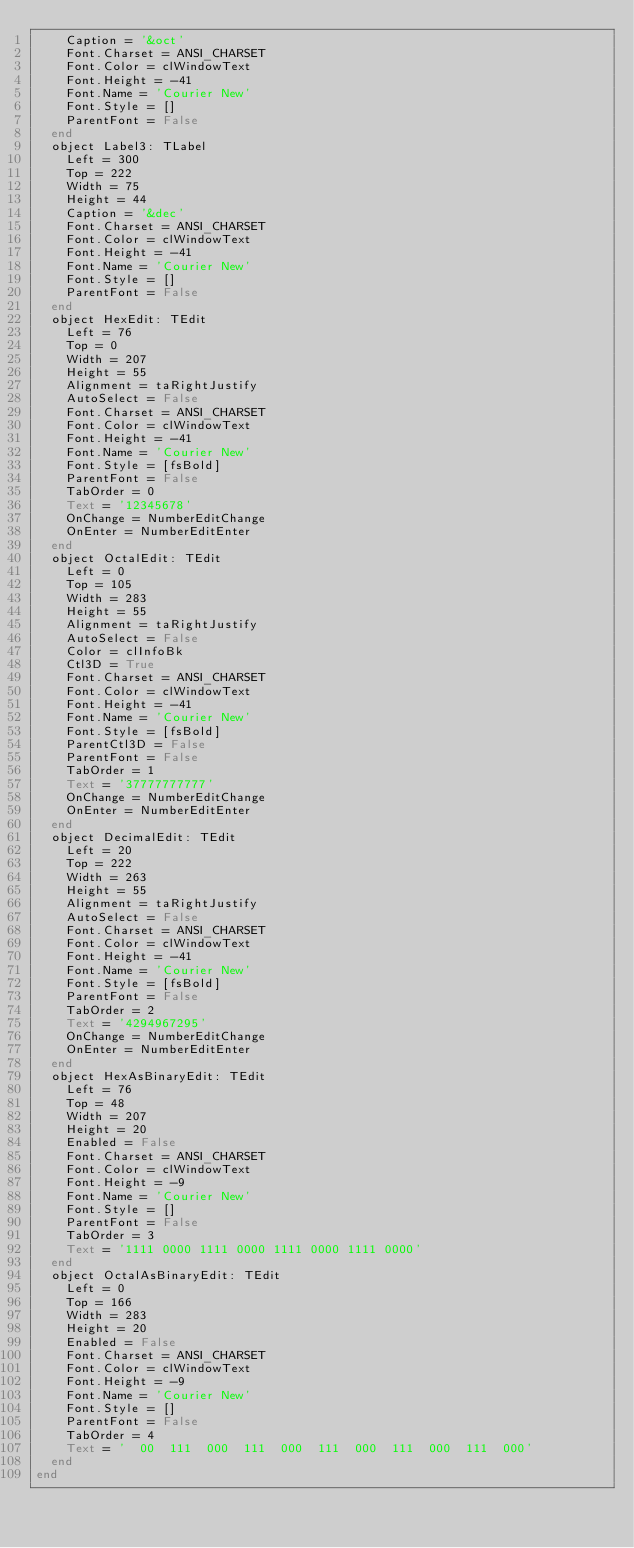<code> <loc_0><loc_0><loc_500><loc_500><_Pascal_>    Caption = '&oct'
    Font.Charset = ANSI_CHARSET
    Font.Color = clWindowText
    Font.Height = -41
    Font.Name = 'Courier New'
    Font.Style = []
    ParentFont = False
  end
  object Label3: TLabel
    Left = 300
    Top = 222
    Width = 75
    Height = 44
    Caption = '&dec'
    Font.Charset = ANSI_CHARSET
    Font.Color = clWindowText
    Font.Height = -41
    Font.Name = 'Courier New'
    Font.Style = []
    ParentFont = False
  end
  object HexEdit: TEdit
    Left = 76
    Top = 0
    Width = 207
    Height = 55
    Alignment = taRightJustify
    AutoSelect = False
    Font.Charset = ANSI_CHARSET
    Font.Color = clWindowText
    Font.Height = -41
    Font.Name = 'Courier New'
    Font.Style = [fsBold]
    ParentFont = False
    TabOrder = 0
    Text = '12345678'
    OnChange = NumberEditChange
    OnEnter = NumberEditEnter
  end
  object OctalEdit: TEdit
    Left = 0
    Top = 105
    Width = 283
    Height = 55
    Alignment = taRightJustify
    AutoSelect = False
    Color = clInfoBk
    Ctl3D = True
    Font.Charset = ANSI_CHARSET
    Font.Color = clWindowText
    Font.Height = -41
    Font.Name = 'Courier New'
    Font.Style = [fsBold]
    ParentCtl3D = False
    ParentFont = False
    TabOrder = 1
    Text = '37777777777'
    OnChange = NumberEditChange
    OnEnter = NumberEditEnter
  end
  object DecimalEdit: TEdit
    Left = 20
    Top = 222
    Width = 263
    Height = 55
    Alignment = taRightJustify
    AutoSelect = False
    Font.Charset = ANSI_CHARSET
    Font.Color = clWindowText
    Font.Height = -41
    Font.Name = 'Courier New'
    Font.Style = [fsBold]
    ParentFont = False
    TabOrder = 2
    Text = '4294967295'
    OnChange = NumberEditChange
    OnEnter = NumberEditEnter
  end
  object HexAsBinaryEdit: TEdit
    Left = 76
    Top = 48
    Width = 207
    Height = 20
    Enabled = False
    Font.Charset = ANSI_CHARSET
    Font.Color = clWindowText
    Font.Height = -9
    Font.Name = 'Courier New'
    Font.Style = []
    ParentFont = False
    TabOrder = 3
    Text = '1111 0000 1111 0000 1111 0000 1111 0000'
  end
  object OctalAsBinaryEdit: TEdit
    Left = 0
    Top = 166
    Width = 283
    Height = 20
    Enabled = False
    Font.Charset = ANSI_CHARSET
    Font.Color = clWindowText
    Font.Height = -9
    Font.Name = 'Courier New'
    Font.Style = []
    ParentFont = False
    TabOrder = 4
    Text = '  00  111  000  111  000  111  000  111  000  111  000'
  end
end
</code> 